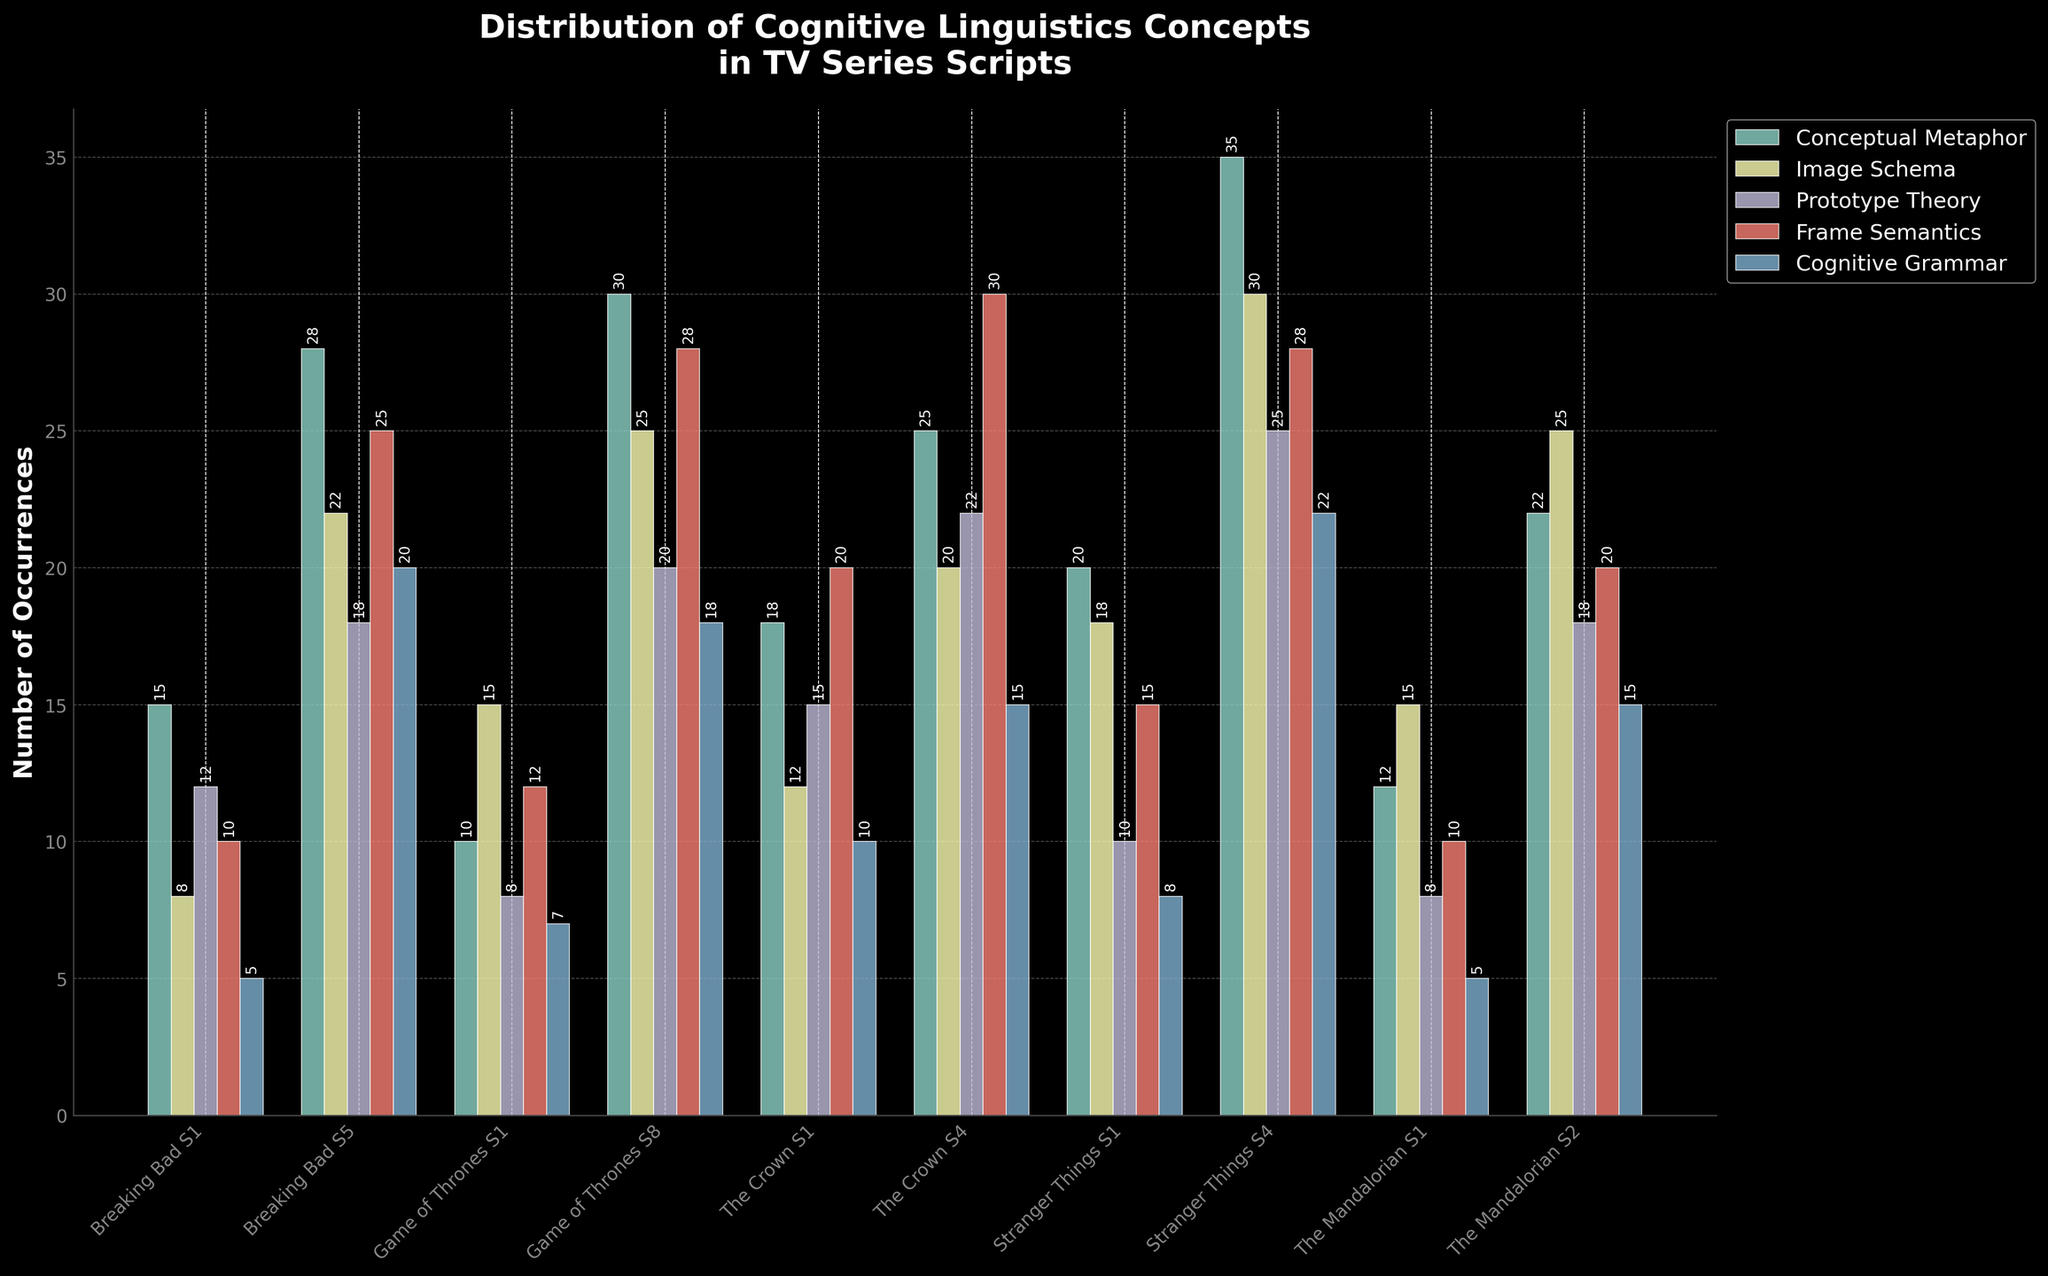What is the most common cognitive linguistics concept used in "Breaking Bad S5"? Look at the heights of the bars for "Breaking Bad S5" and compare them. The highest bar will indicate the most common concept.
Answer: Conceptual Metaphor Which TV series has the highest count of Cognitive Grammar usage in its latest season shown? Identify the highest bar in the Cognitive Grammar category for the most recent season of each series. Compare their heights to find the tallest bar.
Answer: Stranger Things S4 In "Stranger Things S4", which cognitive linguistics concept has the lowest count? Identify the bar with the shortest height for "Stranger Things S4".
Answer: Cognitive Grammar Which season of "Game of Thrones" shows a higher variety in usage count across different cognitive linguistics concepts? Compare the spread of the heights of bars for both "Game of Thrones S1" and "Game of Thrones S8". The season with the wider spread shows a higher variety.
Answer: Game of Thrones S8 